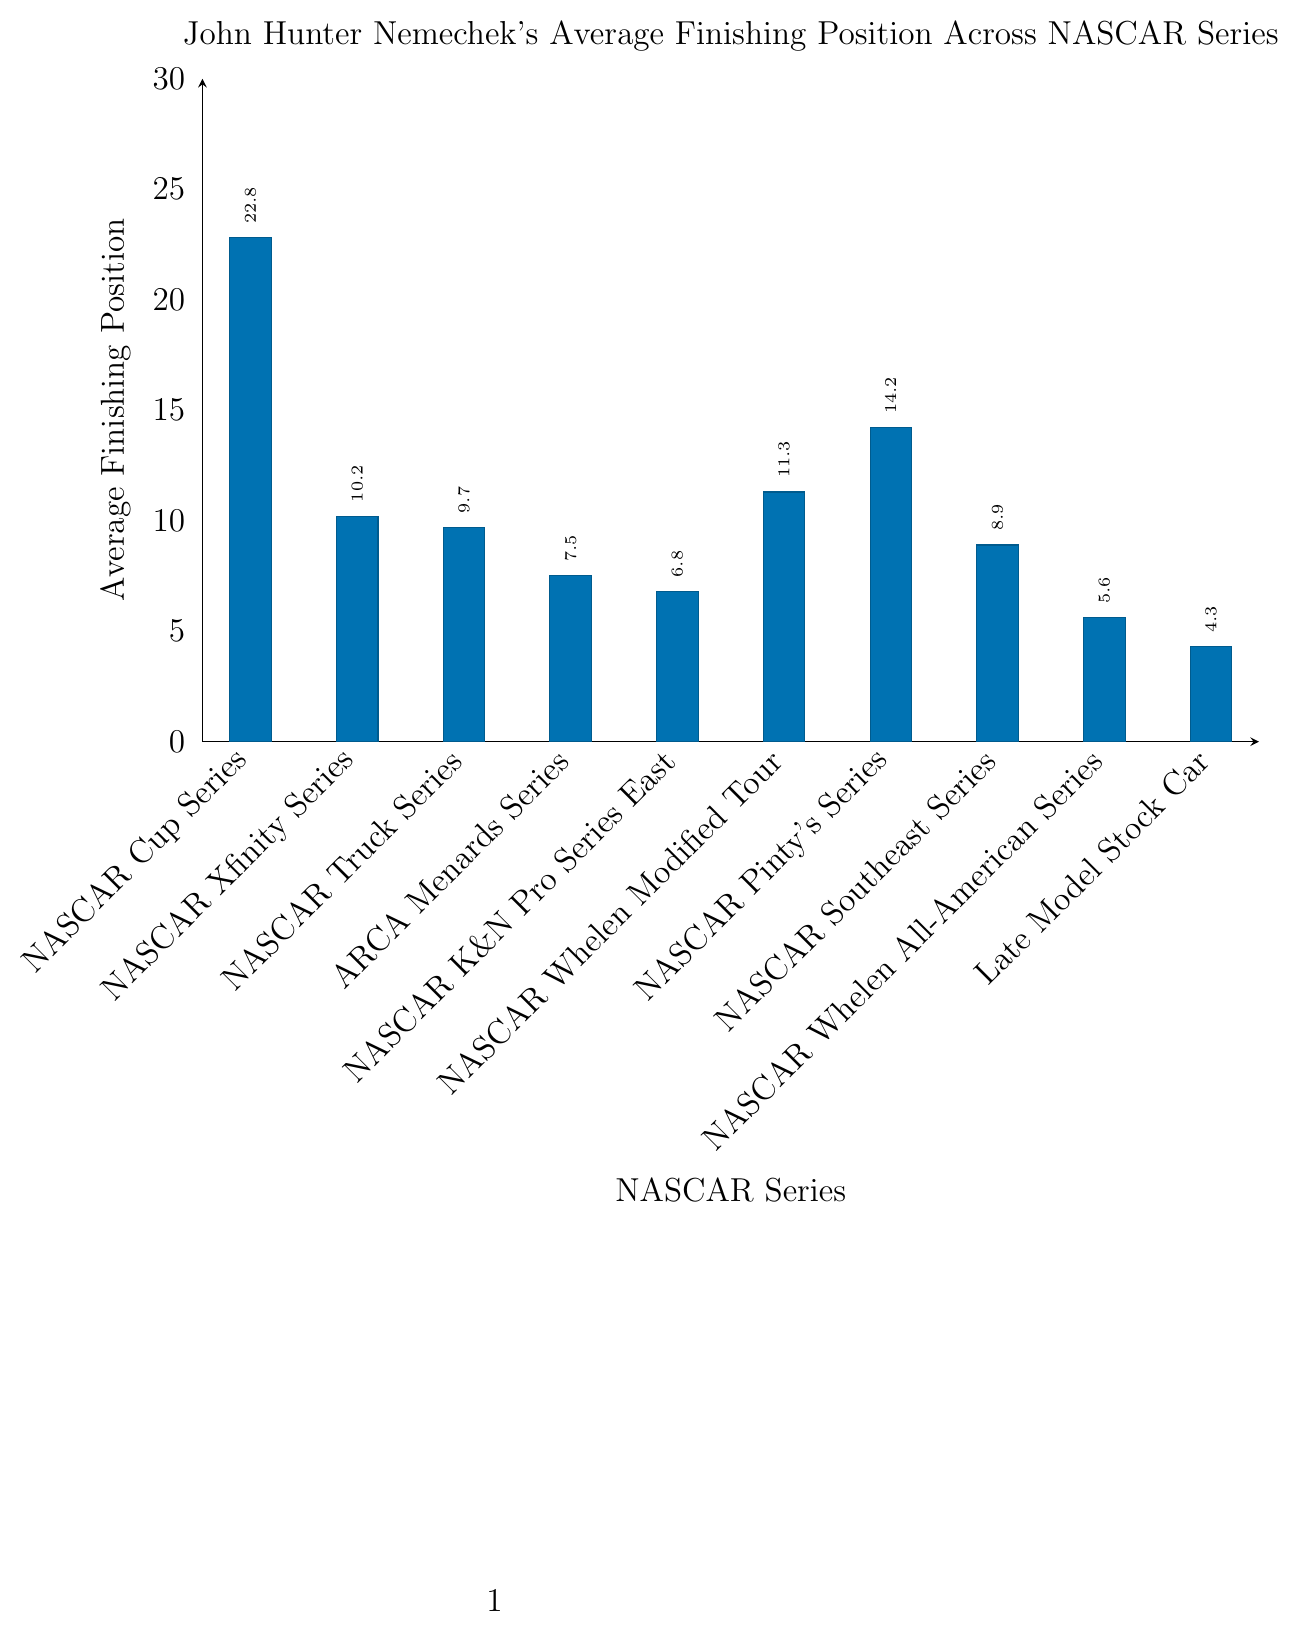Which NASCAR series has the lowest average finishing position for John Hunter Nemechek? The lowest average finishing position corresponds to the lowest bar in the graph. The bar for the Late Model Stock Car series is the smallest, indicating the lowest average finishing position.
Answer: Late Model Stock Car Which NASCAR series has the highest average finishing position for John Hunter Nemechek? The highest average finishing position corresponds to the highest bar in the graph. The bar for the NASCAR Cup Series is the tallest, indicating the highest average finishing position.
Answer: NASCAR Cup Series What is the difference in average finishing position between the NASCAR Xfinity Series and the Late Model Stock Car series for John Hunter Nemechek? The average finishing position for the NASCAR Xfinity Series is 10.2, and for the Late Model Stock Car series, it is 4.3. The difference is calculated as 10.2 - 4.3.
Answer: 5.9 How much higher is John Hunter Nemechek's average finishing position in the NASCAR Whelen Modified Tour compared to the NASCAR K&N Pro Series East? The average finishing position in the NASCAR Whelen Modified Tour is 11.3, and in the NASCAR K&N Pro Series East, it is 6.8. The difference is calculated as 11.3 - 6.8.
Answer: 4.5 What’s the average of John Hunter Nemechek's average finishing positions across all series? Sum all the average finishing positions and then divide by the number of series. The sum is 22.8 + 10.2 + 9.7 + 7.5 + 6.8 + 11.3 + 14.2 + 8.9 + 5.6 + 4.3 = 101.3, and there are 10 series. The average is 101.3 / 10.
Answer: 10.13 How does John Hunter Nemechek’s average finishing position in the NASCAR Cup Series compare to the NASCAR Pinty's Series? The average finishing position in the NASCAR Cup Series is 22.8, whereas in the NASCAR Pinty's Series, it is 14.2. Thus, the position in the NASCAR Cup Series is higher than in the NASCAR Pinty's Series.
Answer: Higher in NASCAR Cup Series Between the NASCAR Southeast Series and the NASCAR Whelen Modified Tour, in which series does John Hunter Nemechek have a better average finishing position? The NASCAR Southeast Series has an average finishing position of 8.9 while the NASCAR Whelen Modified Tour has 11.3, indicating a better performance in the NASCAR Southeast Series.
Answer: NASCAR Southeast Series Identify the series with an average finishing position closest to 10 for John Hunter Nemechek. Compare the average finishing positions to 10. The NASCAR Xfinity Series has an average finishing position of 10.2, which is the closest to 10.
Answer: NASCAR Xfinity Series Which series shows a better average finishing position for John Hunter Nemechek compared to the ARCA Menards Series? All the series with an average finishing position less than 7.5 (ARCA Menards Series). These series are NASCAR K&N Pro Series East, NASCAR Whelen All-American Series, and Late Model Stock Car.
Answer: NASCAR K&N Pro Series East, NASCAR Whelen All-American Series, Late Model Stock Car 